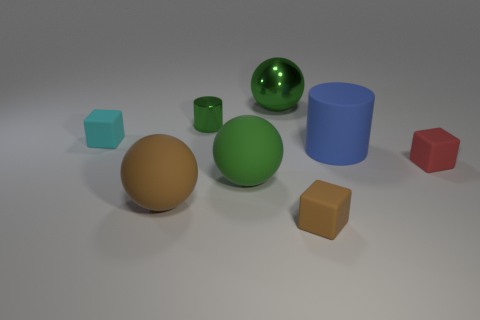The big matte sphere that is left of the tiny cylinder that is in front of the large object that is behind the small cyan matte object is what color?
Provide a short and direct response. Brown. Does the cylinder that is in front of the cyan thing have the same color as the tiny object behind the tiny cyan cube?
Provide a short and direct response. No. There is a green shiny object to the left of the big green object that is in front of the tiny cyan matte thing; what shape is it?
Offer a terse response. Cylinder. Are there any blue spheres that have the same size as the green matte ball?
Offer a very short reply. No. How many other green metallic things have the same shape as the large green metallic object?
Offer a terse response. 0. Are there an equal number of big green metal balls that are to the right of the cyan rubber thing and blue matte things that are in front of the shiny sphere?
Provide a succinct answer. Yes. Are there any blue things?
Ensure brevity in your answer.  Yes. What size is the green sphere in front of the tiny green thing behind the matte ball that is on the right side of the shiny cylinder?
Provide a short and direct response. Large. What shape is the green metal thing that is the same size as the green matte thing?
Offer a very short reply. Sphere. Is there any other thing that has the same material as the big brown thing?
Keep it short and to the point. Yes. 